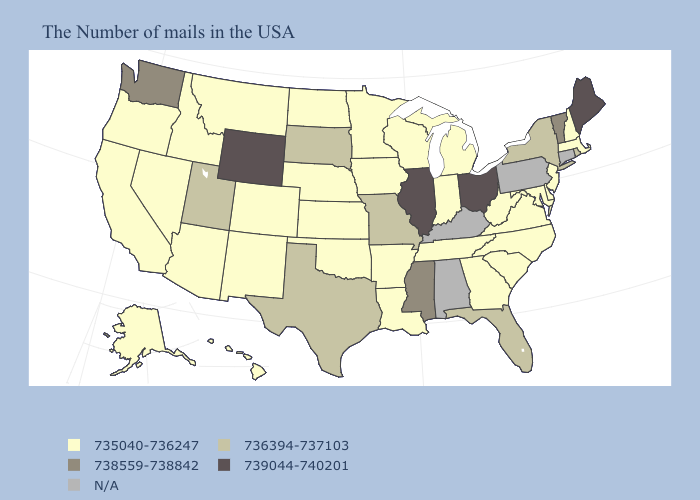Does Hawaii have the lowest value in the West?
Quick response, please. Yes. Does Utah have the lowest value in the USA?
Concise answer only. No. Does Michigan have the lowest value in the MidWest?
Be succinct. Yes. What is the value of Arkansas?
Answer briefly. 735040-736247. Is the legend a continuous bar?
Give a very brief answer. No. Is the legend a continuous bar?
Concise answer only. No. How many symbols are there in the legend?
Short answer required. 5. Which states have the lowest value in the South?
Concise answer only. Delaware, Maryland, Virginia, North Carolina, South Carolina, West Virginia, Georgia, Tennessee, Louisiana, Arkansas, Oklahoma. What is the lowest value in the MidWest?
Answer briefly. 735040-736247. Which states hav the highest value in the West?
Give a very brief answer. Wyoming. What is the value of Georgia?
Quick response, please. 735040-736247. Name the states that have a value in the range 735040-736247?
Concise answer only. Massachusetts, New Hampshire, New Jersey, Delaware, Maryland, Virginia, North Carolina, South Carolina, West Virginia, Georgia, Michigan, Indiana, Tennessee, Wisconsin, Louisiana, Arkansas, Minnesota, Iowa, Kansas, Nebraska, Oklahoma, North Dakota, Colorado, New Mexico, Montana, Arizona, Idaho, Nevada, California, Oregon, Alaska, Hawaii. Among the states that border Georgia , does South Carolina have the lowest value?
Concise answer only. Yes. Among the states that border Texas , which have the highest value?
Short answer required. Louisiana, Arkansas, Oklahoma, New Mexico. 